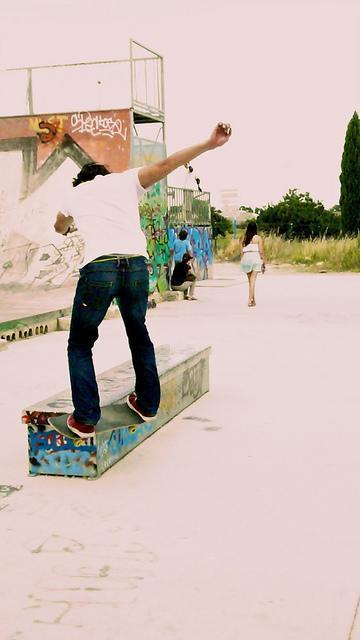Why si the board hanging from the box?
Pick the right solution, then justify: 'Answer: answer
Rationale: rationale.'
Options: Is stuck, bounced there, showing off, fell there. Answer: showing off.
Rationale: The board is showing off. 